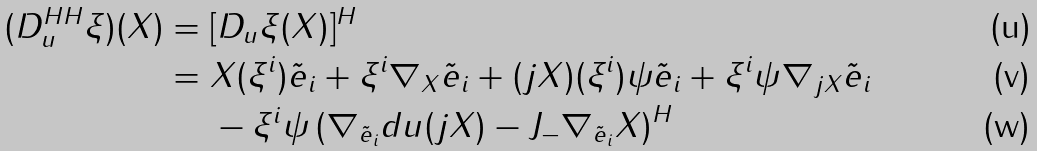<formula> <loc_0><loc_0><loc_500><loc_500>( D _ { u } ^ { H H } \xi ) ( X ) & = [ D _ { u } \xi ( X ) ] ^ { H } \\ & = X ( \xi ^ { i } ) \tilde { e } _ { i } + \xi ^ { i } \nabla _ { X } \tilde { e } _ { i } + ( j X ) ( \xi ^ { i } ) \psi \tilde { e } _ { i } + \xi ^ { i } \psi \nabla _ { j X } \tilde { e } _ { i } \\ & \quad \ - \xi ^ { i } \psi \left ( \nabla _ { \tilde { e } _ { i } } d u ( j X ) - J _ { - } \nabla _ { \tilde { e } _ { i } } X \right ) ^ { H }</formula> 